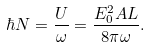Convert formula to latex. <formula><loc_0><loc_0><loc_500><loc_500>\hbar { N } = \frac { U } { \omega } = \frac { E _ { 0 } ^ { 2 } A L } { 8 \pi \omega } .</formula> 